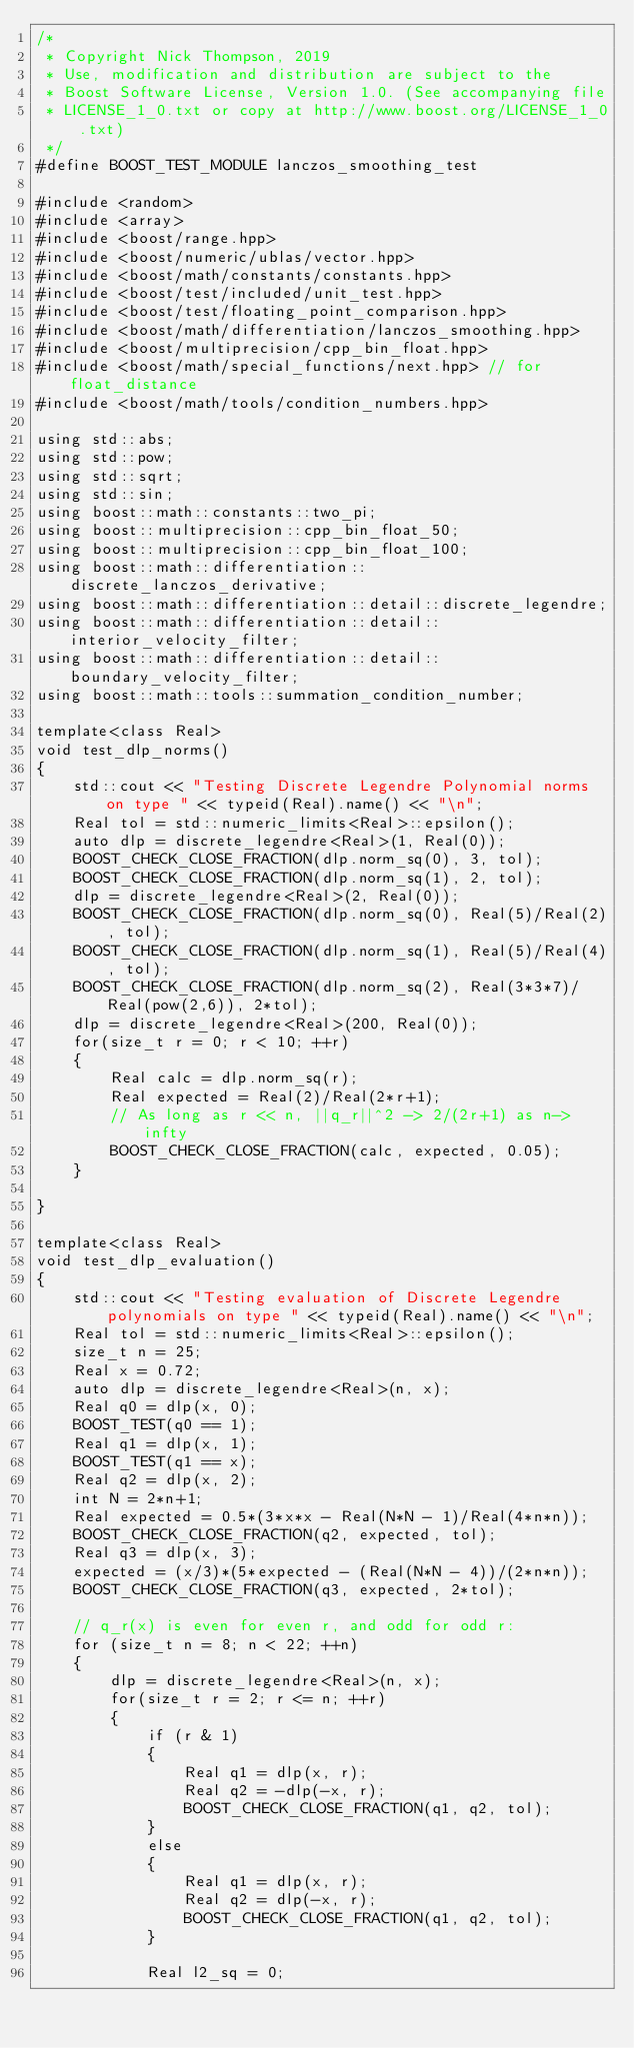Convert code to text. <code><loc_0><loc_0><loc_500><loc_500><_C++_>/*
 * Copyright Nick Thompson, 2019
 * Use, modification and distribution are subject to the
 * Boost Software License, Version 1.0. (See accompanying file
 * LICENSE_1_0.txt or copy at http://www.boost.org/LICENSE_1_0.txt)
 */
#define BOOST_TEST_MODULE lanczos_smoothing_test

#include <random>
#include <array>
#include <boost/range.hpp>
#include <boost/numeric/ublas/vector.hpp>
#include <boost/math/constants/constants.hpp>
#include <boost/test/included/unit_test.hpp>
#include <boost/test/floating_point_comparison.hpp>
#include <boost/math/differentiation/lanczos_smoothing.hpp>
#include <boost/multiprecision/cpp_bin_float.hpp>
#include <boost/math/special_functions/next.hpp> // for float_distance
#include <boost/math/tools/condition_numbers.hpp>

using std::abs;
using std::pow;
using std::sqrt;
using std::sin;
using boost::math::constants::two_pi;
using boost::multiprecision::cpp_bin_float_50;
using boost::multiprecision::cpp_bin_float_100;
using boost::math::differentiation::discrete_lanczos_derivative;
using boost::math::differentiation::detail::discrete_legendre;
using boost::math::differentiation::detail::interior_velocity_filter;
using boost::math::differentiation::detail::boundary_velocity_filter;
using boost::math::tools::summation_condition_number;

template<class Real>
void test_dlp_norms()
{
    std::cout << "Testing Discrete Legendre Polynomial norms on type " << typeid(Real).name() << "\n";
    Real tol = std::numeric_limits<Real>::epsilon();
    auto dlp = discrete_legendre<Real>(1, Real(0));
    BOOST_CHECK_CLOSE_FRACTION(dlp.norm_sq(0), 3, tol);
    BOOST_CHECK_CLOSE_FRACTION(dlp.norm_sq(1), 2, tol);
    dlp = discrete_legendre<Real>(2, Real(0));
    BOOST_CHECK_CLOSE_FRACTION(dlp.norm_sq(0), Real(5)/Real(2), tol);
    BOOST_CHECK_CLOSE_FRACTION(dlp.norm_sq(1), Real(5)/Real(4), tol);
    BOOST_CHECK_CLOSE_FRACTION(dlp.norm_sq(2), Real(3*3*7)/Real(pow(2,6)), 2*tol);
    dlp = discrete_legendre<Real>(200, Real(0));
    for(size_t r = 0; r < 10; ++r)
    {
        Real calc = dlp.norm_sq(r);
        Real expected = Real(2)/Real(2*r+1);
        // As long as r << n, ||q_r||^2 -> 2/(2r+1) as n->infty
        BOOST_CHECK_CLOSE_FRACTION(calc, expected, 0.05);
    }

}

template<class Real>
void test_dlp_evaluation()
{
    std::cout << "Testing evaluation of Discrete Legendre polynomials on type " << typeid(Real).name() << "\n";
    Real tol = std::numeric_limits<Real>::epsilon();
    size_t n = 25;
    Real x = 0.72;
    auto dlp = discrete_legendre<Real>(n, x);
    Real q0 = dlp(x, 0);
    BOOST_TEST(q0 == 1);
    Real q1 = dlp(x, 1);
    BOOST_TEST(q1 == x);
    Real q2 = dlp(x, 2);
    int N = 2*n+1;
    Real expected = 0.5*(3*x*x - Real(N*N - 1)/Real(4*n*n));
    BOOST_CHECK_CLOSE_FRACTION(q2, expected, tol);
    Real q3 = dlp(x, 3);
    expected = (x/3)*(5*expected - (Real(N*N - 4))/(2*n*n));
    BOOST_CHECK_CLOSE_FRACTION(q3, expected, 2*tol);

    // q_r(x) is even for even r, and odd for odd r:
    for (size_t n = 8; n < 22; ++n)
    {
        dlp = discrete_legendre<Real>(n, x);
        for(size_t r = 2; r <= n; ++r)
        {
            if (r & 1)
            {
                Real q1 = dlp(x, r);
                Real q2 = -dlp(-x, r);
                BOOST_CHECK_CLOSE_FRACTION(q1, q2, tol);
            }
            else
            {
                Real q1 = dlp(x, r);
                Real q2 = dlp(-x, r);
                BOOST_CHECK_CLOSE_FRACTION(q1, q2, tol);
            }

            Real l2_sq = 0;</code> 